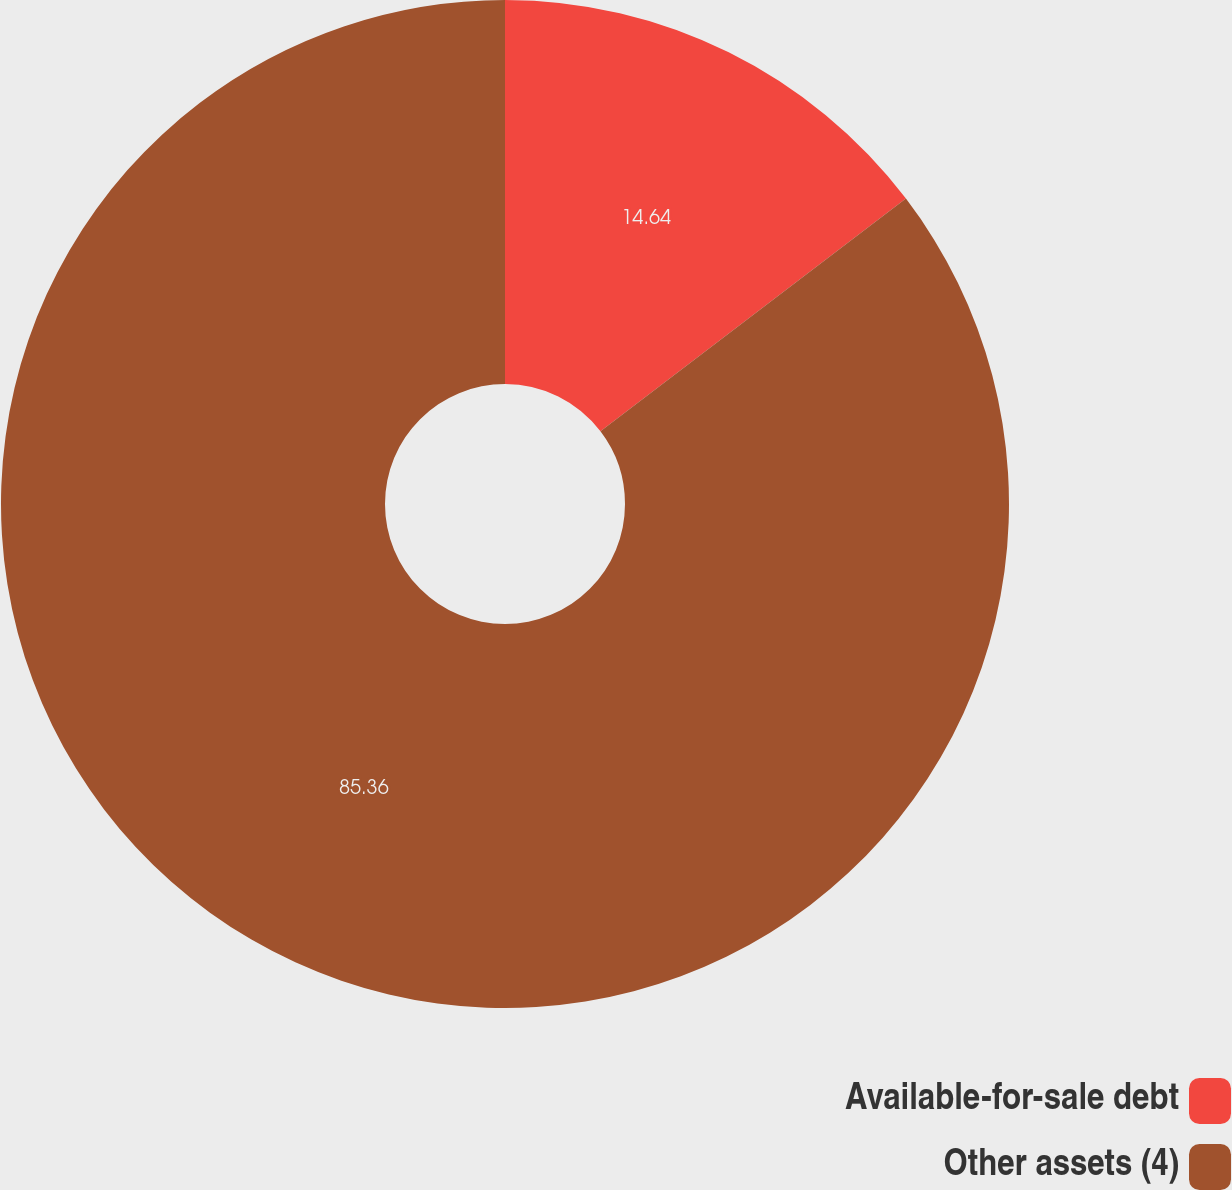<chart> <loc_0><loc_0><loc_500><loc_500><pie_chart><fcel>Available-for-sale debt<fcel>Other assets (4)<nl><fcel>14.64%<fcel>85.36%<nl></chart> 